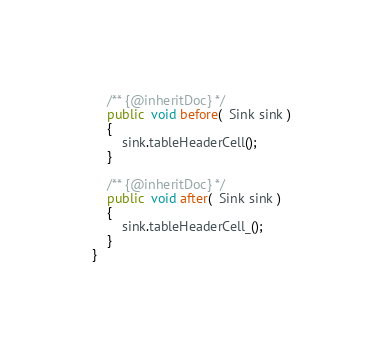<code> <loc_0><loc_0><loc_500><loc_500><_Java_>    /** {@inheritDoc} */
    public  void before(  Sink sink )
    {
        sink.tableHeaderCell();
    }

    /** {@inheritDoc} */
    public  void after(  Sink sink )
    {
        sink.tableHeaderCell_();
    }
}
</code> 